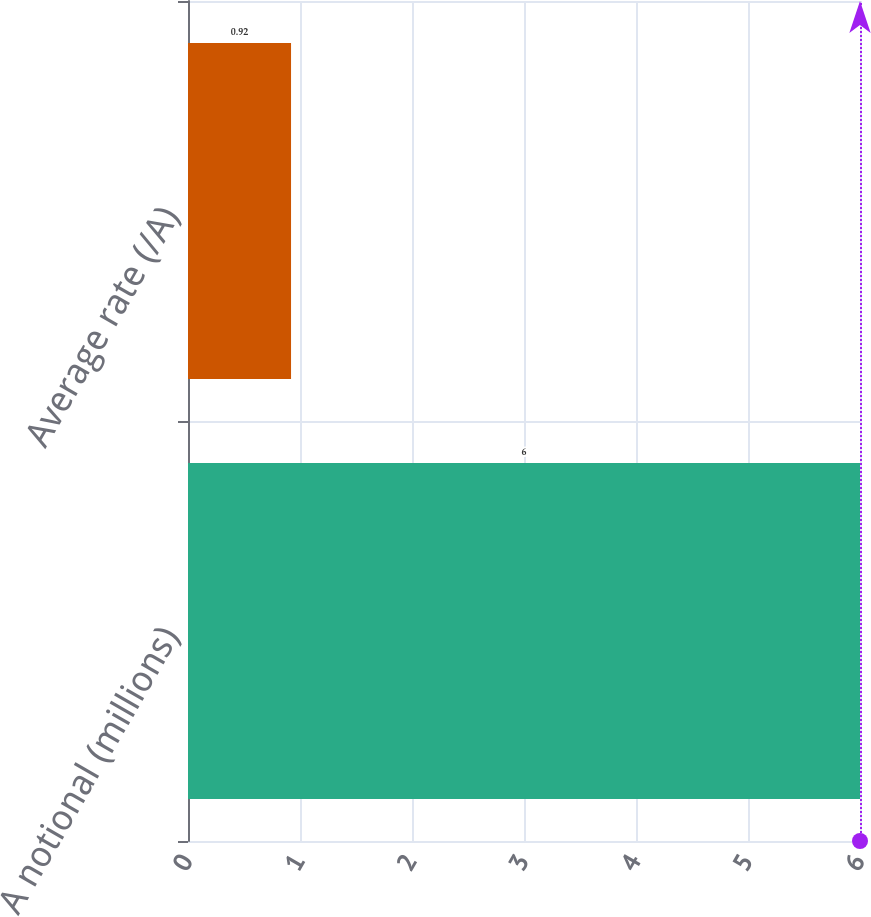Convert chart. <chart><loc_0><loc_0><loc_500><loc_500><bar_chart><fcel>A notional (millions)<fcel>Average rate (/A)<nl><fcel>6<fcel>0.92<nl></chart> 